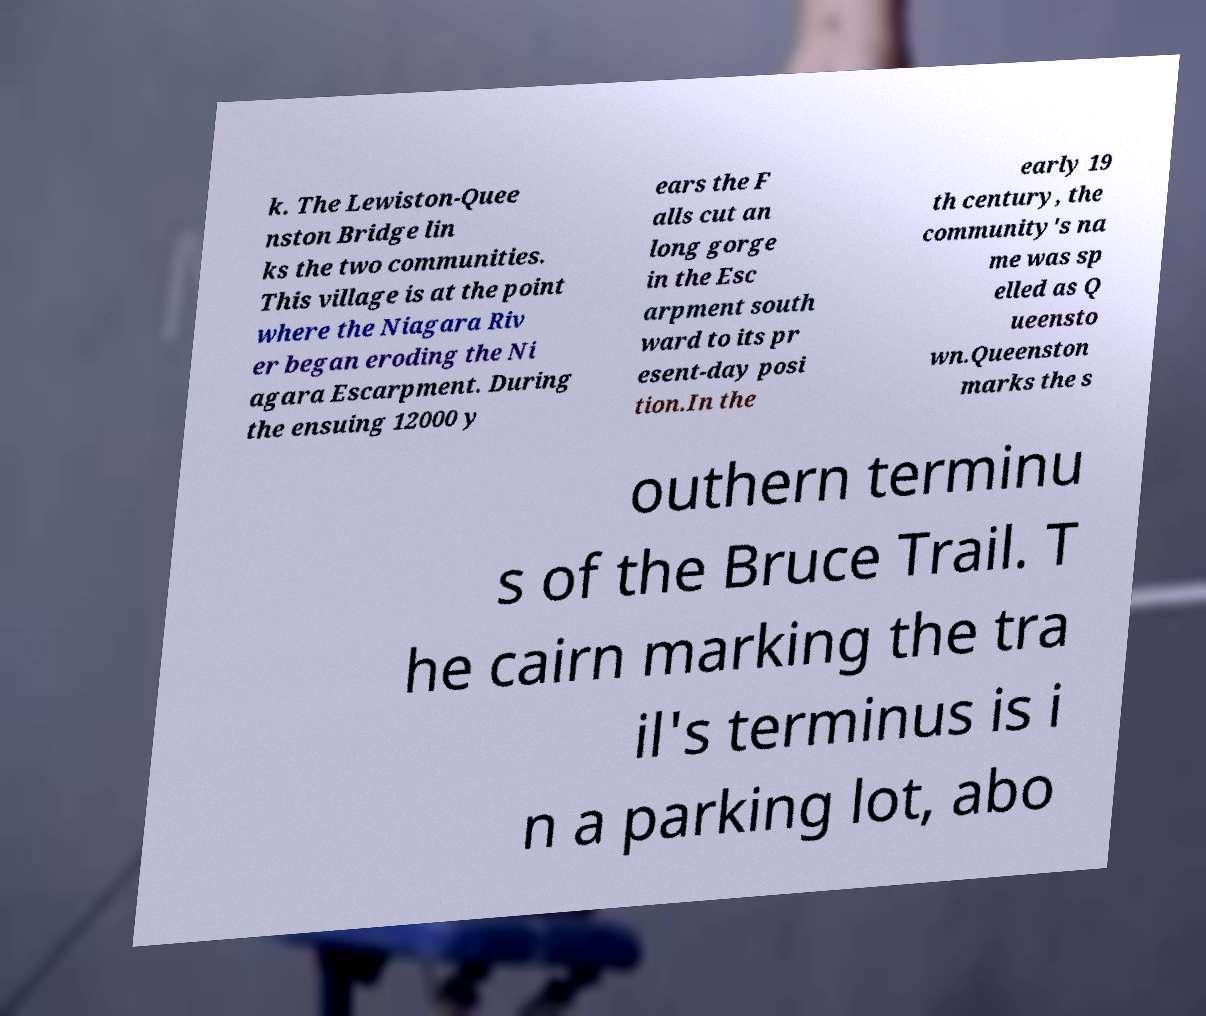Could you extract and type out the text from this image? k. The Lewiston-Quee nston Bridge lin ks the two communities. This village is at the point where the Niagara Riv er began eroding the Ni agara Escarpment. During the ensuing 12000 y ears the F alls cut an long gorge in the Esc arpment south ward to its pr esent-day posi tion.In the early 19 th century, the community's na me was sp elled as Q ueensto wn.Queenston marks the s outhern terminu s of the Bruce Trail. T he cairn marking the tra il's terminus is i n a parking lot, abo 